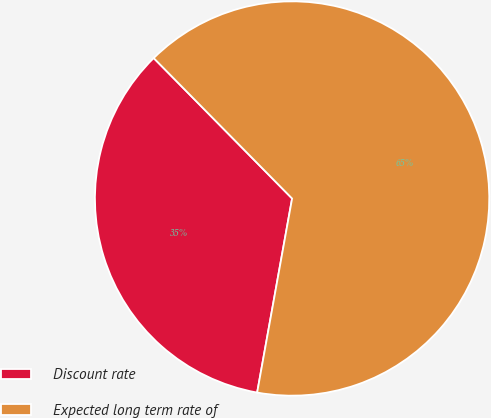<chart> <loc_0><loc_0><loc_500><loc_500><pie_chart><fcel>Discount rate<fcel>Expected long term rate of<nl><fcel>34.78%<fcel>65.22%<nl></chart> 